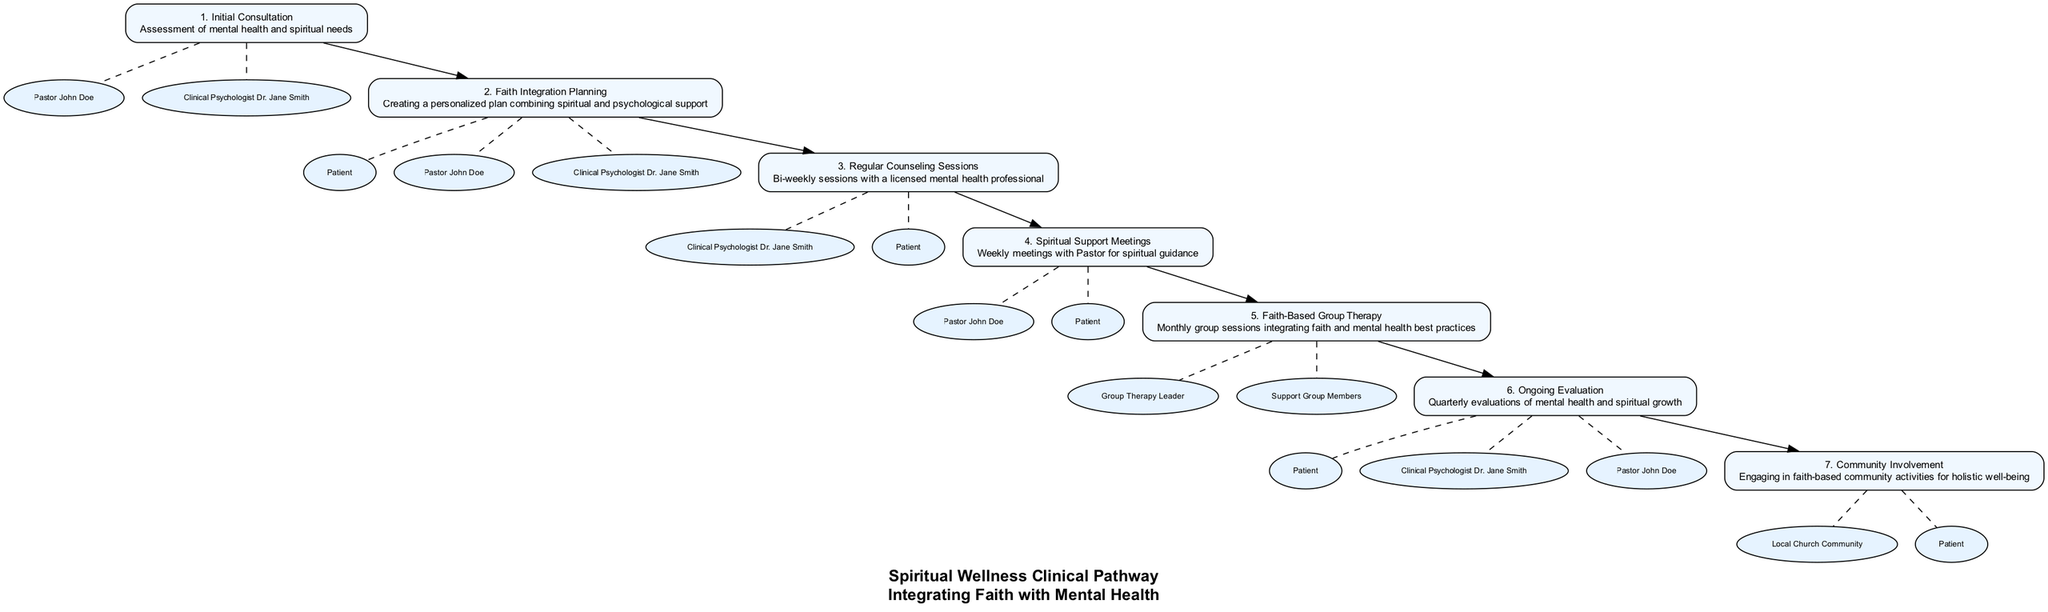What is the first step in the Spiritual Wellness Clinical Pathway? The first step listed in the diagram is "Initial Consultation", which involves the assessment of mental health and spiritual needs.
Answer: Initial Consultation How many steps are there in the pathway? By counting the steps listed, it can be determined that there are a total of seven steps in the pathway.
Answer: 7 What entities are involved in the "Faith Integration Planning"? The entities involved in this step include the Patient, Pastor John Doe, and Clinical Psychologist Dr. Jane Smith, as indicated in the diagram.
Answer: Patient, Pastor John Doe, Clinical Psychologist Dr. Jane Smith Which step occurs after "Regular Counseling Sessions"? According to the flow of the pathway, after "Regular Counseling Sessions", the next step is "Spiritual Support Meetings".
Answer: Spiritual Support Meetings What type of support does "Ongoing Evaluation" provide? This step provides a quarterly evaluation of both mental health and spiritual growth, showing the integration of these aspects in the pathway.
Answer: Evaluation of mental health and spiritual growth Which step includes engaging in community activities? The "Community Involvement" step specifically mentions engaging in faith-based community activities for holistic well-being.
Answer: Community Involvement How frequently are the "Regular Counseling Sessions" held? The diagram states that "Regular Counseling Sessions" are bi-weekly, meaning they occur every two weeks.
Answer: Bi-weekly What is the purpose of "Faith-Based Group Therapy"? "Faith-Based Group Therapy" aims to provide monthly group sessions that integrate faith and mental health best practices, as shown in the description.
Answer: Integration of faith and mental health best practices What is the relationship between "Ongoing Evaluation" and the entities involved? In the "Ongoing Evaluation" step, the entities involved are the Patient, Clinical Psychologist Dr. Jane Smith, and Pastor John Doe, indicating a collaborative approach to evaluate growth.
Answer: Collaborative evaluation with Patient, Clinical Psychologist Dr. Jane Smith, Pastor John Doe 